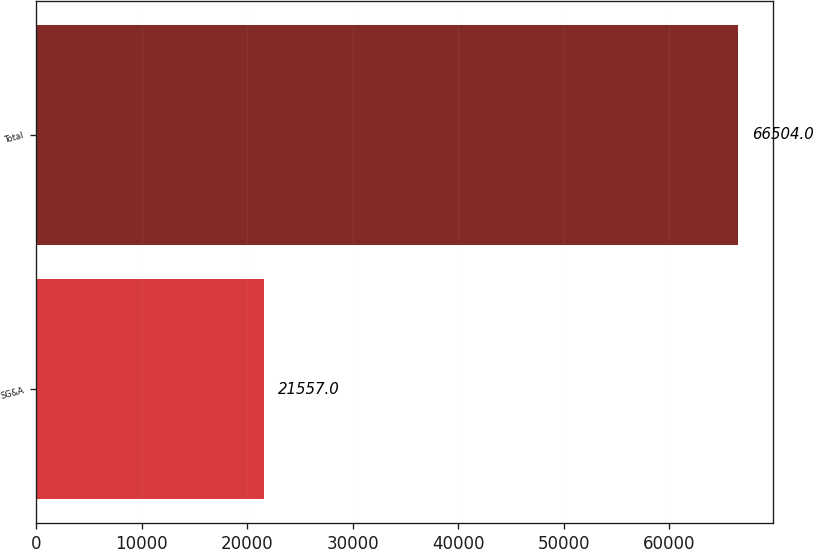<chart> <loc_0><loc_0><loc_500><loc_500><bar_chart><fcel>SG&A<fcel>Total<nl><fcel>21557<fcel>66504<nl></chart> 